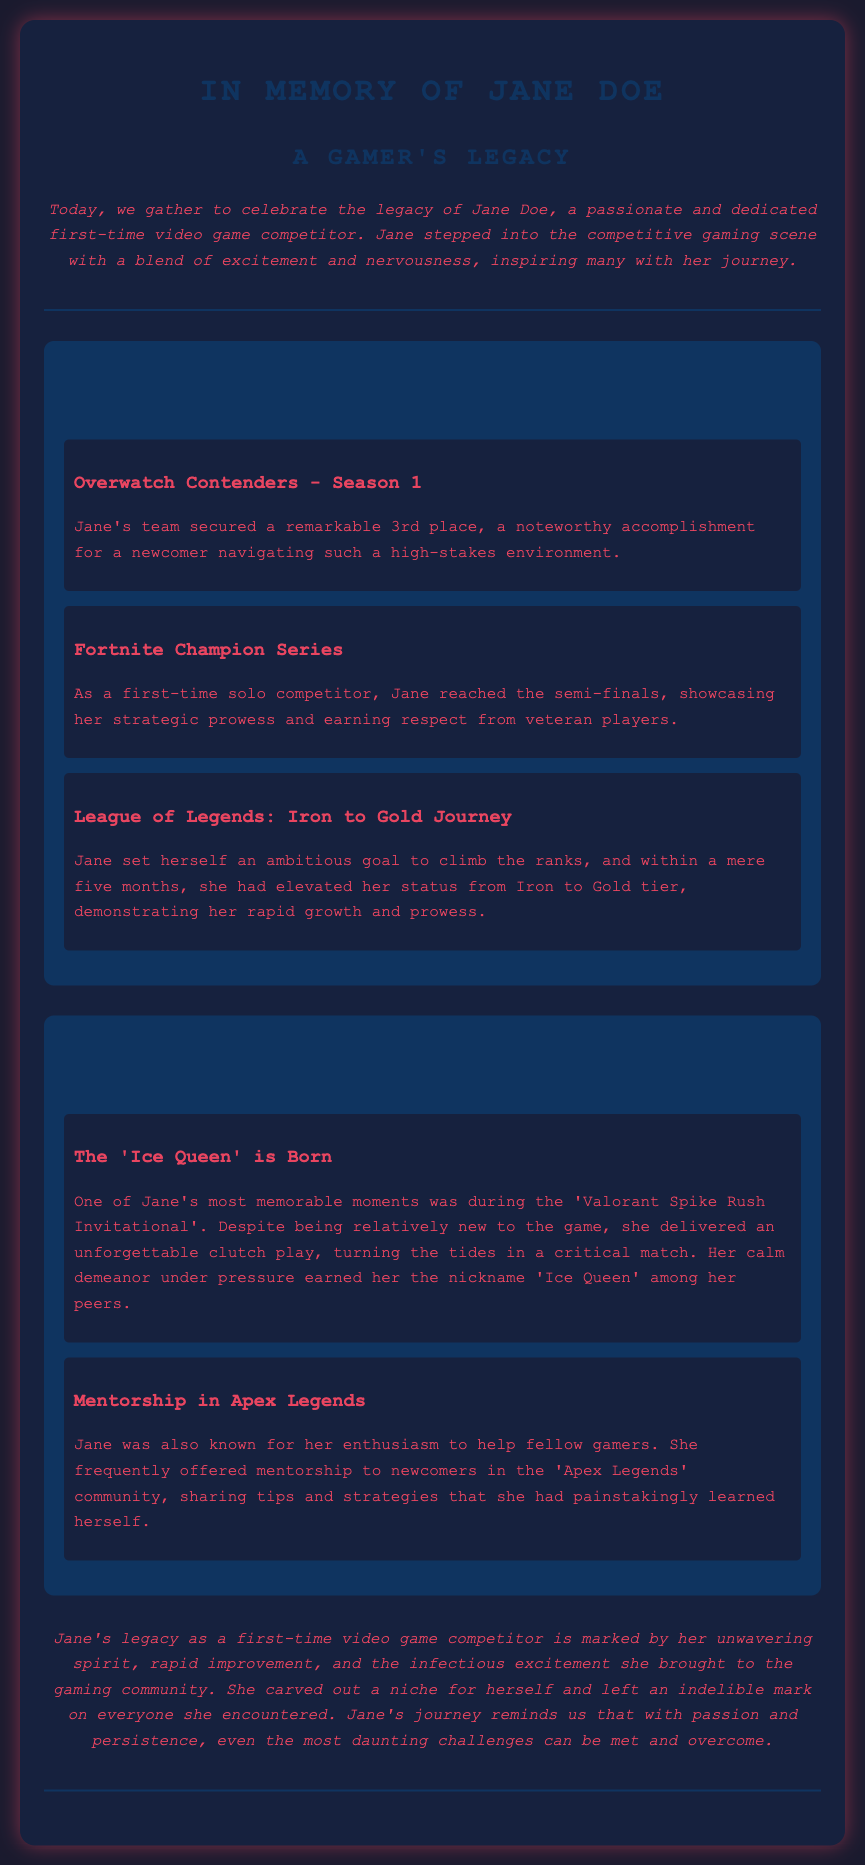What was Jane's team placement in Overwatch Contenders - Season 1? The document states that Jane's team secured a remarkable 3rd place in this competition.
Answer: 3rd place What nickname did Jane earn among her peers? The document mentions that her calm demeanor under pressure earned her the nickname 'Ice Queen'.
Answer: Ice Queen In how many months did Jane elevate her status from Iron to Gold tier in League of Legends? The document indicates that Jane accomplished this in a mere five months.
Answer: five months What was Jane's achievement in the Fortnite Champion Series? According to the document, Jane reached the semi-finals in this competition.
Answer: semi-finals Which game did Jane deliver an unforgettable clutch play in? The document specifies that this memorable moment occurred during the 'Valorant Spike Rush Invitational'.
Answer: Valorant How did Jane contribute to the Apex Legends community? The document states that she frequently offered mentorship to newcomers.
Answer: mentorship What is the overall theme of Jane's legacy as a competitor? The document describes her legacy as marked by unwavering spirit and rapid improvement.
Answer: unwavering spirit What event marked the creation of the nickname "Ice Queen"? The document reveals that it was during the 'Valorant Spike Rush Invitational'.
Answer: Valorant Spike Rush Invitational What type of competitor was Jane described as? The document characterizes Jane as a first-time video game competitor.
Answer: first-time competitor 